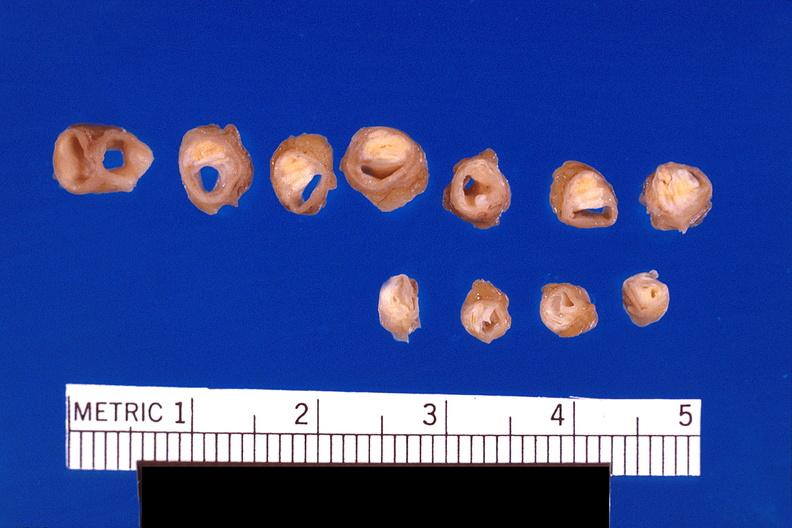s cardiovascular present?
Answer the question using a single word or phrase. Yes 